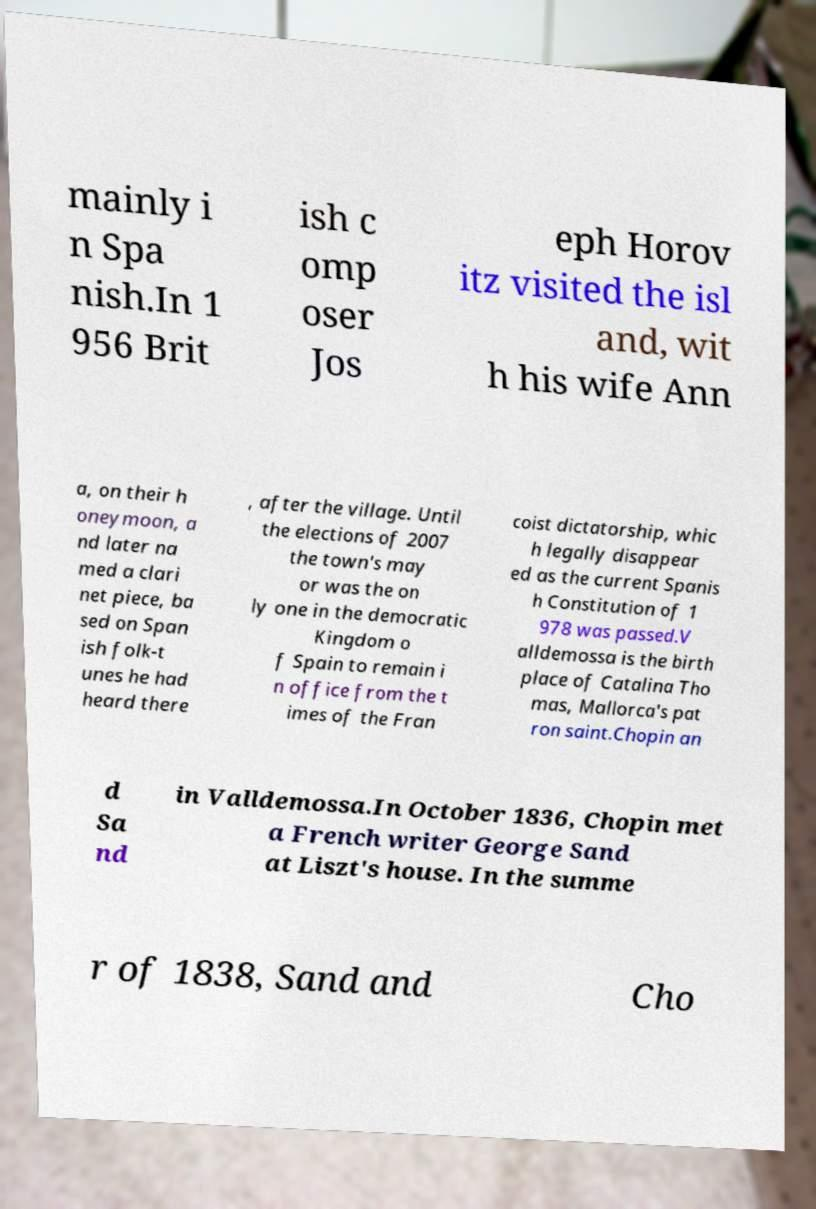For documentation purposes, I need the text within this image transcribed. Could you provide that? mainly i n Spa nish.In 1 956 Brit ish c omp oser Jos eph Horov itz visited the isl and, wit h his wife Ann a, on their h oneymoon, a nd later na med a clari net piece, ba sed on Span ish folk-t unes he had heard there , after the village. Until the elections of 2007 the town's may or was the on ly one in the democratic Kingdom o f Spain to remain i n office from the t imes of the Fran coist dictatorship, whic h legally disappear ed as the current Spanis h Constitution of 1 978 was passed.V alldemossa is the birth place of Catalina Tho mas, Mallorca's pat ron saint.Chopin an d Sa nd in Valldemossa.In October 1836, Chopin met a French writer George Sand at Liszt's house. In the summe r of 1838, Sand and Cho 